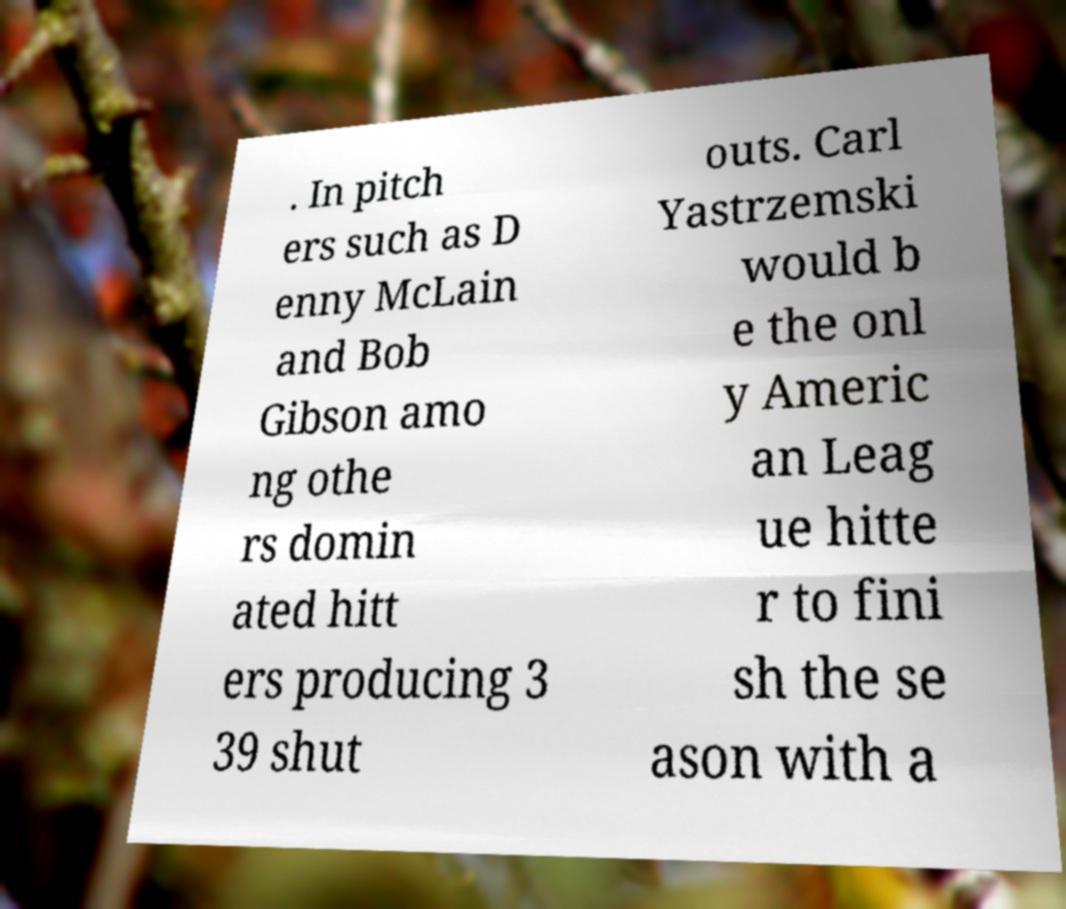I need the written content from this picture converted into text. Can you do that? . In pitch ers such as D enny McLain and Bob Gibson amo ng othe rs domin ated hitt ers producing 3 39 shut outs. Carl Yastrzemski would b e the onl y Americ an Leag ue hitte r to fini sh the se ason with a 